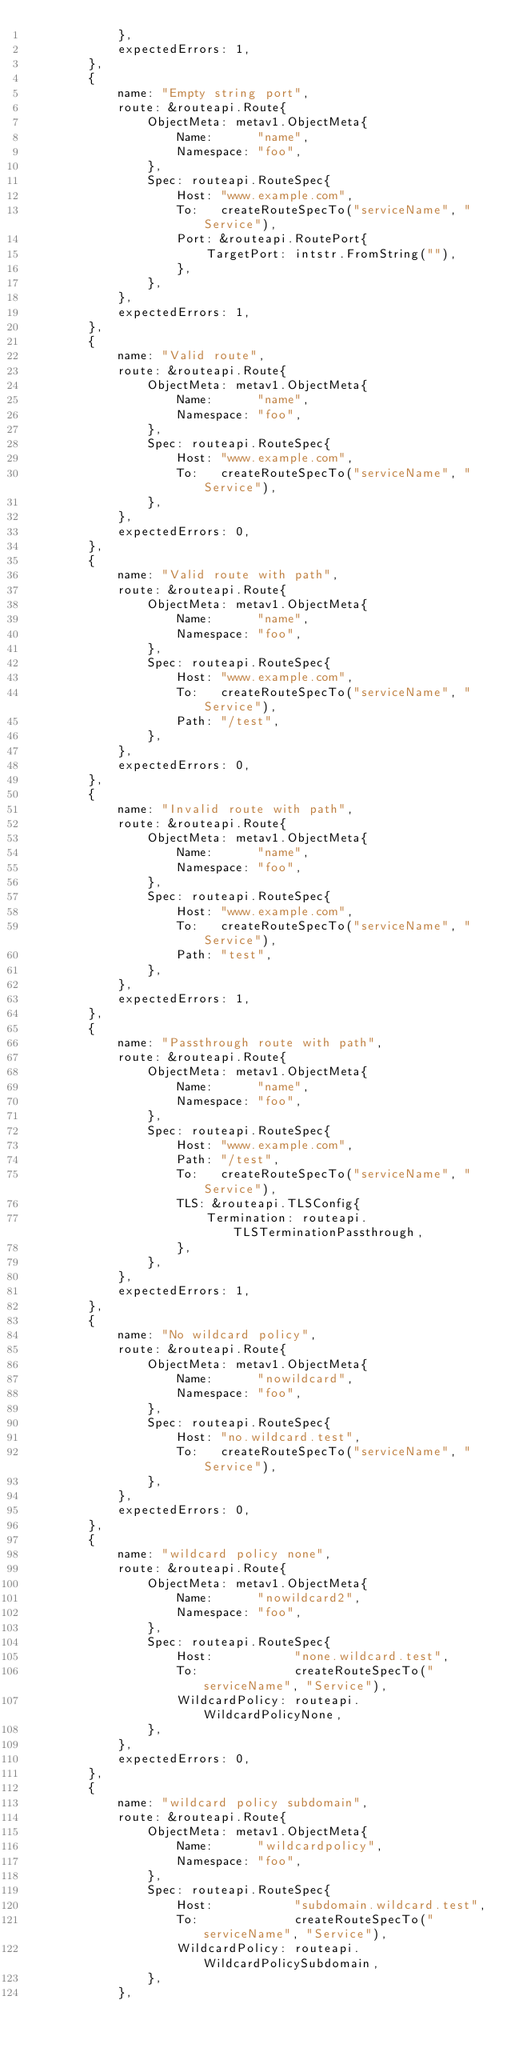<code> <loc_0><loc_0><loc_500><loc_500><_Go_>			},
			expectedErrors: 1,
		},
		{
			name: "Empty string port",
			route: &routeapi.Route{
				ObjectMeta: metav1.ObjectMeta{
					Name:      "name",
					Namespace: "foo",
				},
				Spec: routeapi.RouteSpec{
					Host: "www.example.com",
					To:   createRouteSpecTo("serviceName", "Service"),
					Port: &routeapi.RoutePort{
						TargetPort: intstr.FromString(""),
					},
				},
			},
			expectedErrors: 1,
		},
		{
			name: "Valid route",
			route: &routeapi.Route{
				ObjectMeta: metav1.ObjectMeta{
					Name:      "name",
					Namespace: "foo",
				},
				Spec: routeapi.RouteSpec{
					Host: "www.example.com",
					To:   createRouteSpecTo("serviceName", "Service"),
				},
			},
			expectedErrors: 0,
		},
		{
			name: "Valid route with path",
			route: &routeapi.Route{
				ObjectMeta: metav1.ObjectMeta{
					Name:      "name",
					Namespace: "foo",
				},
				Spec: routeapi.RouteSpec{
					Host: "www.example.com",
					To:   createRouteSpecTo("serviceName", "Service"),
					Path: "/test",
				},
			},
			expectedErrors: 0,
		},
		{
			name: "Invalid route with path",
			route: &routeapi.Route{
				ObjectMeta: metav1.ObjectMeta{
					Name:      "name",
					Namespace: "foo",
				},
				Spec: routeapi.RouteSpec{
					Host: "www.example.com",
					To:   createRouteSpecTo("serviceName", "Service"),
					Path: "test",
				},
			},
			expectedErrors: 1,
		},
		{
			name: "Passthrough route with path",
			route: &routeapi.Route{
				ObjectMeta: metav1.ObjectMeta{
					Name:      "name",
					Namespace: "foo",
				},
				Spec: routeapi.RouteSpec{
					Host: "www.example.com",
					Path: "/test",
					To:   createRouteSpecTo("serviceName", "Service"),
					TLS: &routeapi.TLSConfig{
						Termination: routeapi.TLSTerminationPassthrough,
					},
				},
			},
			expectedErrors: 1,
		},
		{
			name: "No wildcard policy",
			route: &routeapi.Route{
				ObjectMeta: metav1.ObjectMeta{
					Name:      "nowildcard",
					Namespace: "foo",
				},
				Spec: routeapi.RouteSpec{
					Host: "no.wildcard.test",
					To:   createRouteSpecTo("serviceName", "Service"),
				},
			},
			expectedErrors: 0,
		},
		{
			name: "wildcard policy none",
			route: &routeapi.Route{
				ObjectMeta: metav1.ObjectMeta{
					Name:      "nowildcard2",
					Namespace: "foo",
				},
				Spec: routeapi.RouteSpec{
					Host:           "none.wildcard.test",
					To:             createRouteSpecTo("serviceName", "Service"),
					WildcardPolicy: routeapi.WildcardPolicyNone,
				},
			},
			expectedErrors: 0,
		},
		{
			name: "wildcard policy subdomain",
			route: &routeapi.Route{
				ObjectMeta: metav1.ObjectMeta{
					Name:      "wildcardpolicy",
					Namespace: "foo",
				},
				Spec: routeapi.RouteSpec{
					Host:           "subdomain.wildcard.test",
					To:             createRouteSpecTo("serviceName", "Service"),
					WildcardPolicy: routeapi.WildcardPolicySubdomain,
				},
			},</code> 